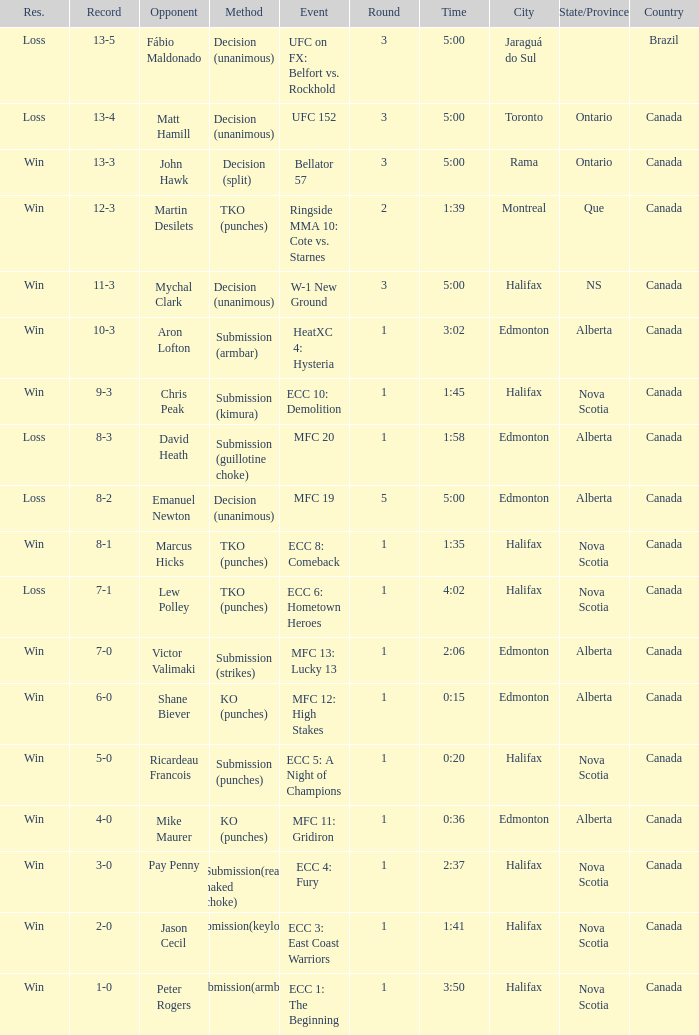What is the method of the match with 1 round and a time of 1:58? Submission (guillotine choke). 